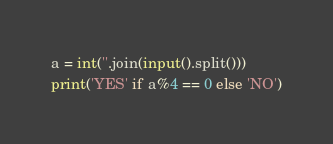Convert code to text. <code><loc_0><loc_0><loc_500><loc_500><_Python_>a = int(''.join(input().split()))
print('YES' if a%4 == 0 else 'NO')</code> 